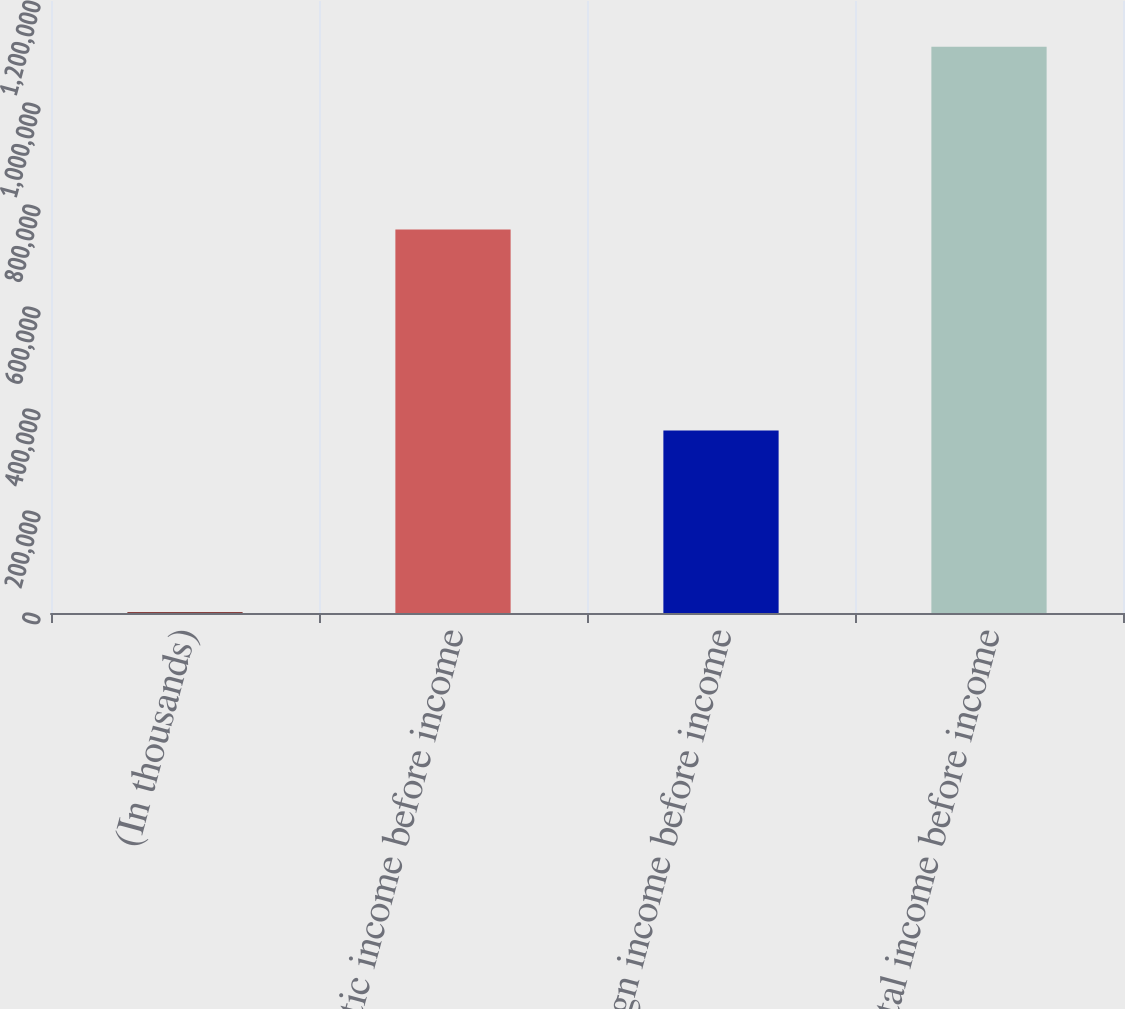Convert chart to OTSL. <chart><loc_0><loc_0><loc_500><loc_500><bar_chart><fcel>(In thousands)<fcel>Domestic income before income<fcel>Foreign income before income<fcel>Total income before income<nl><fcel>2011<fcel>752163<fcel>357903<fcel>1.11007e+06<nl></chart> 